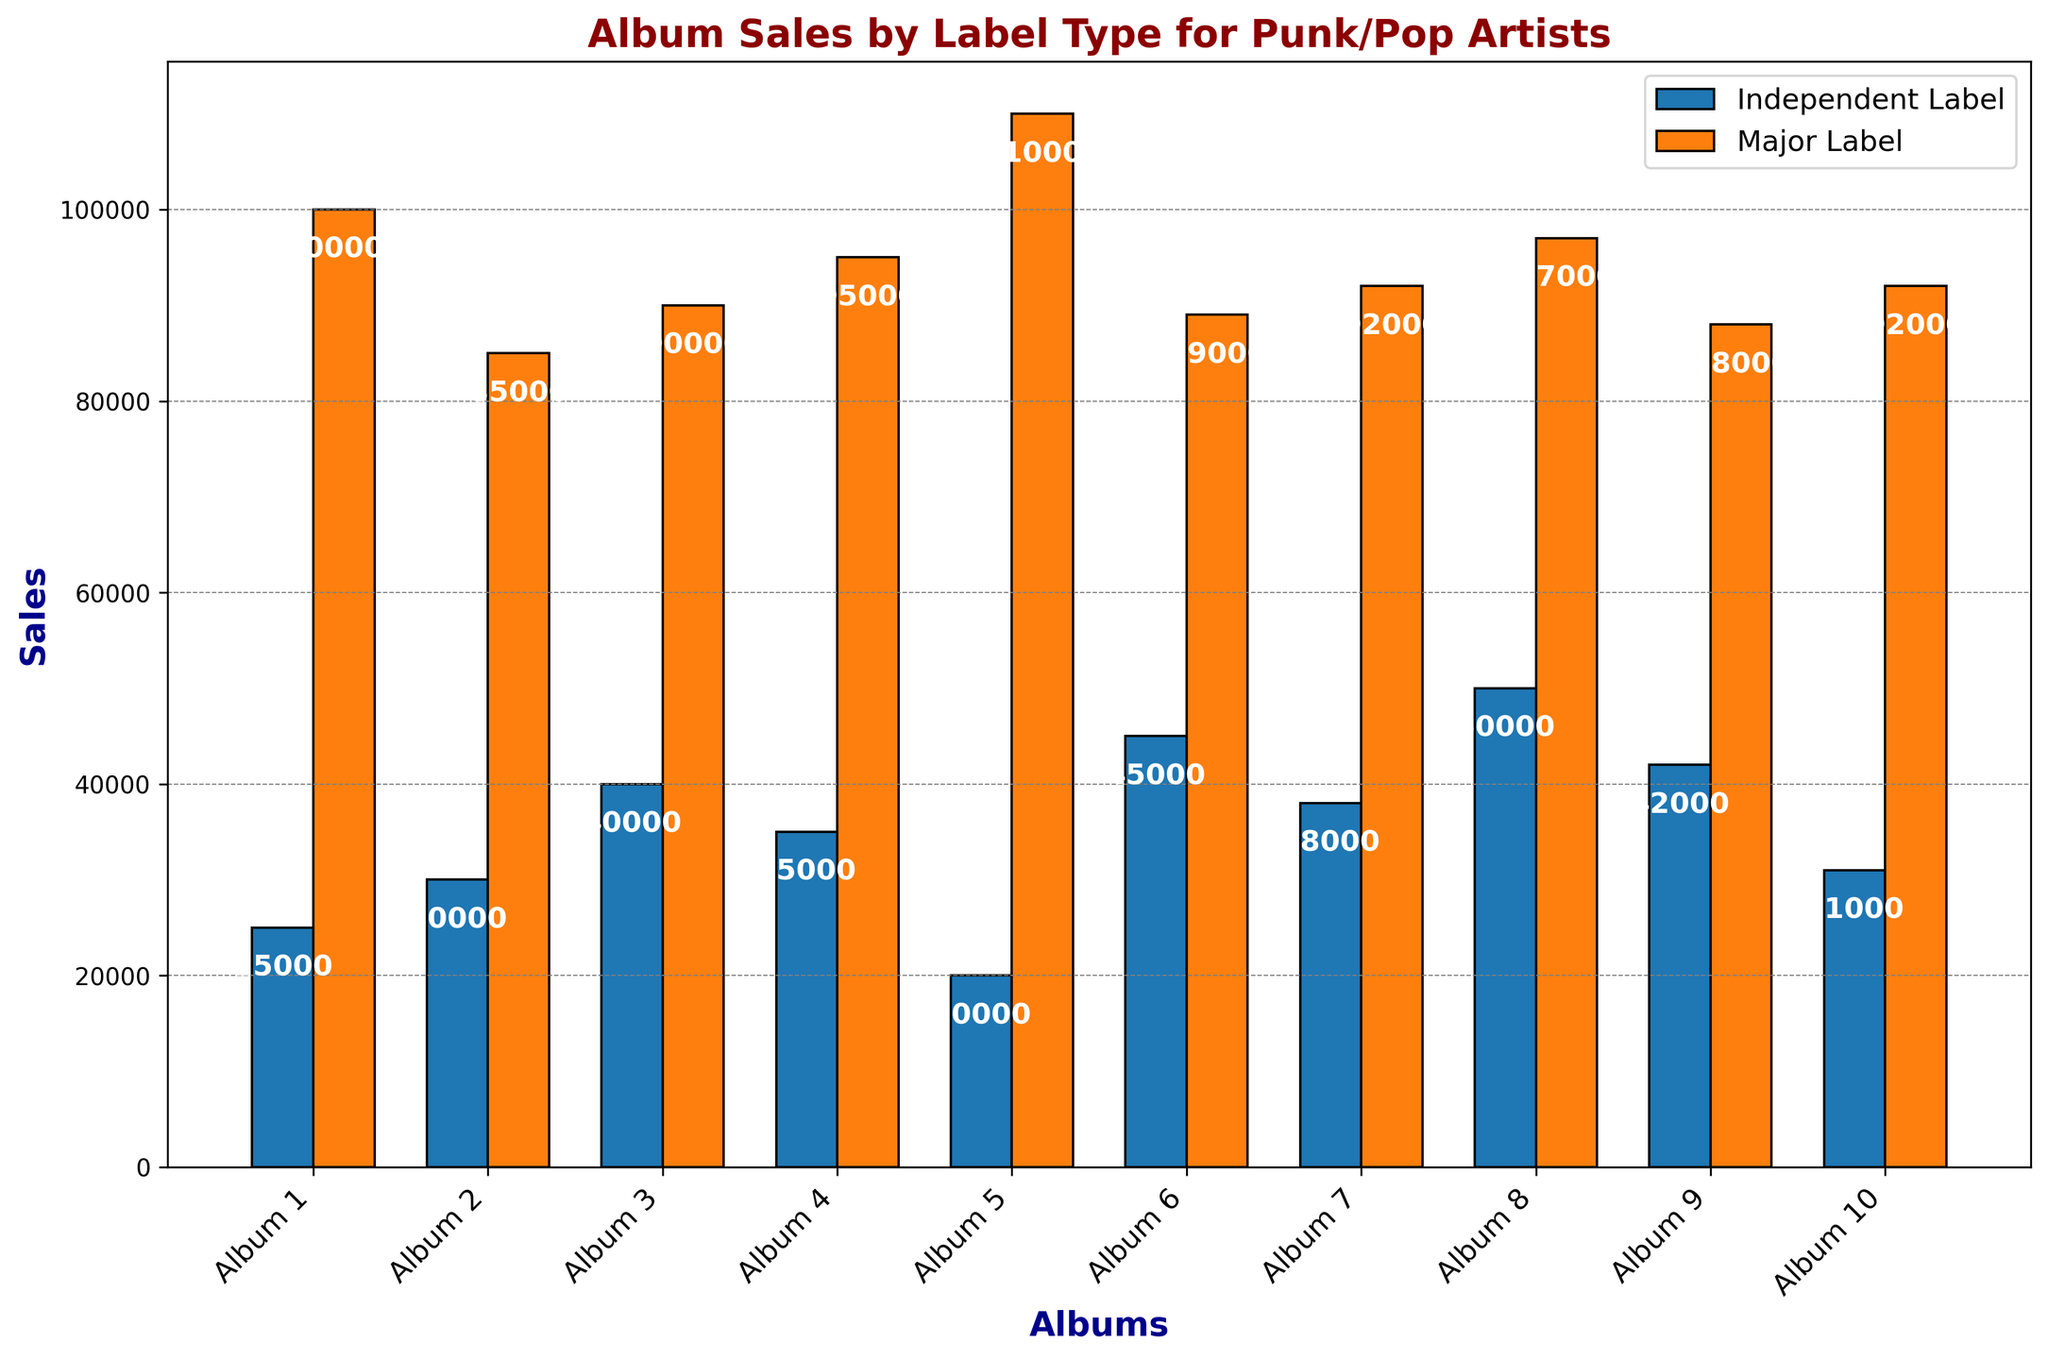What's the total sales for Independent Label albums? Sum the sales values for all Independent Label albums: 25000 + 30000 + 40000 + 35000 + 20000 + 45000 + 38000 + 50000 + 42000 + 31000 = 356000
Answer: 356000 Which album had the highest sales for Major Label and what were those sales? The heights of the bars for Major Label albums should be compared. Album 5 had the highest sales with 110000.
Answer: Album 5, 110000 How much higher are the major label sales than the independent label sales for Album 2? Look at the heights of the bars for Album 2. Major Label: 85000, Independent Label: 30000. The difference is 85000 - 30000 = 55000
Answer: 55000 Which album shows the least difference in sales between the two label types? Calculate the differences for each album: 
Album 1: 75000, Album 2: 55000, Album 3: 50000, Album 4: 60000, Album 5: 90000, Album 6: 44000, Album 7: 54000, Album 8: 47000, Album 9: 46000, Album 10: 61000. 
Album 6 has the smallest difference of 44000.
Answer: Album 6 What's the combined sales for both Independent and Major labels on Album 9? Add the sales values for Independent and Major labels for Album 9: 42000 + 88000 = 130000
Answer: 130000 Compare the average sales for Independent and Major labels. Which is higher? Calculate the average for both:
Independent: (25000 + 30000 + 40000 + 35000 + 20000 + 45000 + 38000 + 50000 + 42000 + 31000) / 10 = 35600
Major: (100000 + 85000 + 90000 + 95000 + 110000 + 89000 + 92000 + 97000 + 88000 + 92000) / 10 = 93300
The Major label’s average is higher.
Answer: Major label How many albums have at least 90000 sales on Major label? Count the bars for Major labels with heights at least 90000. 
There are 6 albums: Album 1, Album 3, Album 4, Album 5, Album 7, Album 10.
Answer: 6 For which album are the sales on Independent label closest to the sales on Major label? Find the minimal difference between sales for each album:
Album 1: 75000, Album 2: 55000, Album 3: 50000, Album 4: 60000, Album 5: 90000, Album 6: 44000, Album 7: 54000, Album 8: 47000, Album 9: 46000, Album 10: 61000.
Album 6 has the smallest difference of 44000.
Answer: Album 6 